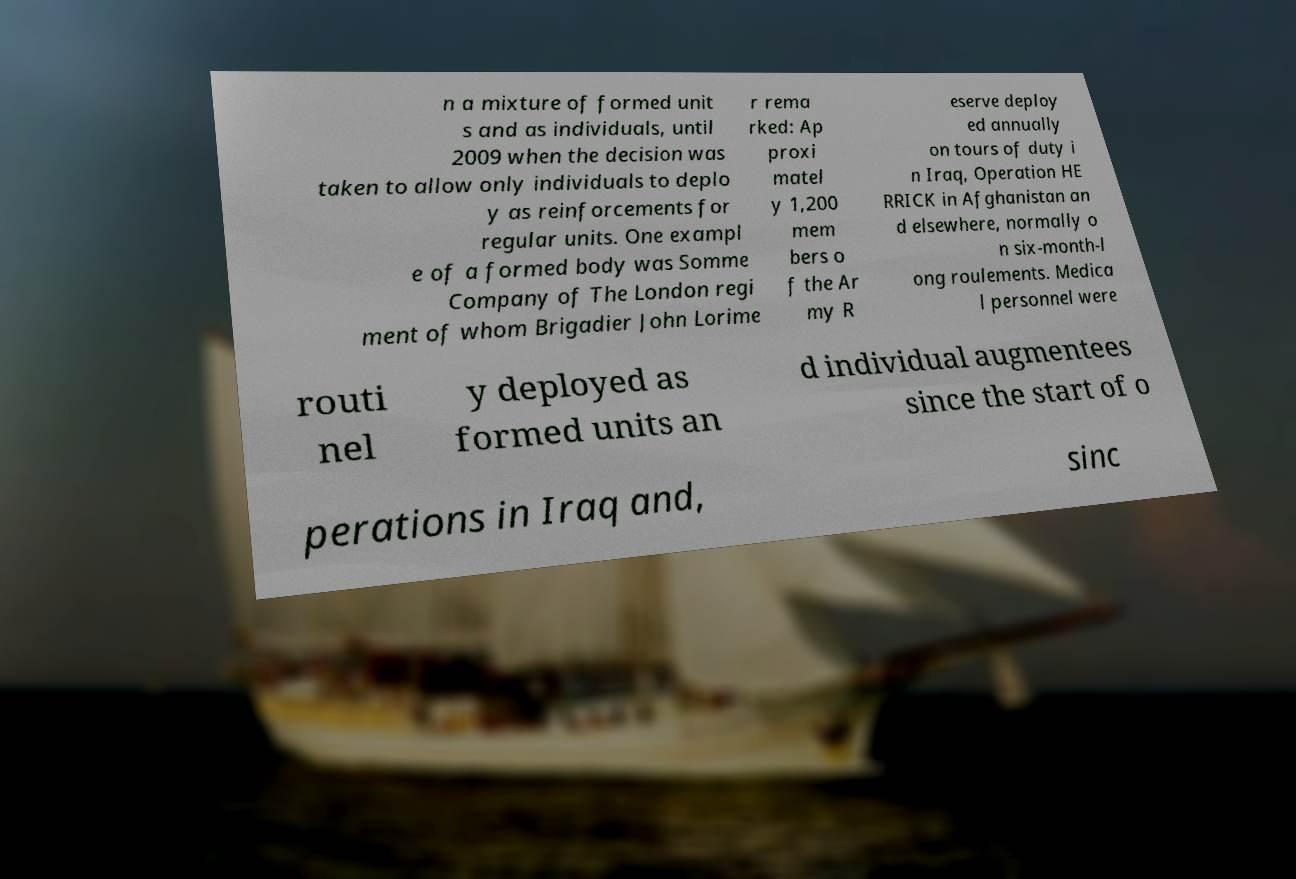Please identify and transcribe the text found in this image. n a mixture of formed unit s and as individuals, until 2009 when the decision was taken to allow only individuals to deplo y as reinforcements for regular units. One exampl e of a formed body was Somme Company of The London regi ment of whom Brigadier John Lorime r rema rked: Ap proxi matel y 1,200 mem bers o f the Ar my R eserve deploy ed annually on tours of duty i n Iraq, Operation HE RRICK in Afghanistan an d elsewhere, normally o n six-month-l ong roulements. Medica l personnel were routi nel y deployed as formed units an d individual augmentees since the start of o perations in Iraq and, sinc 